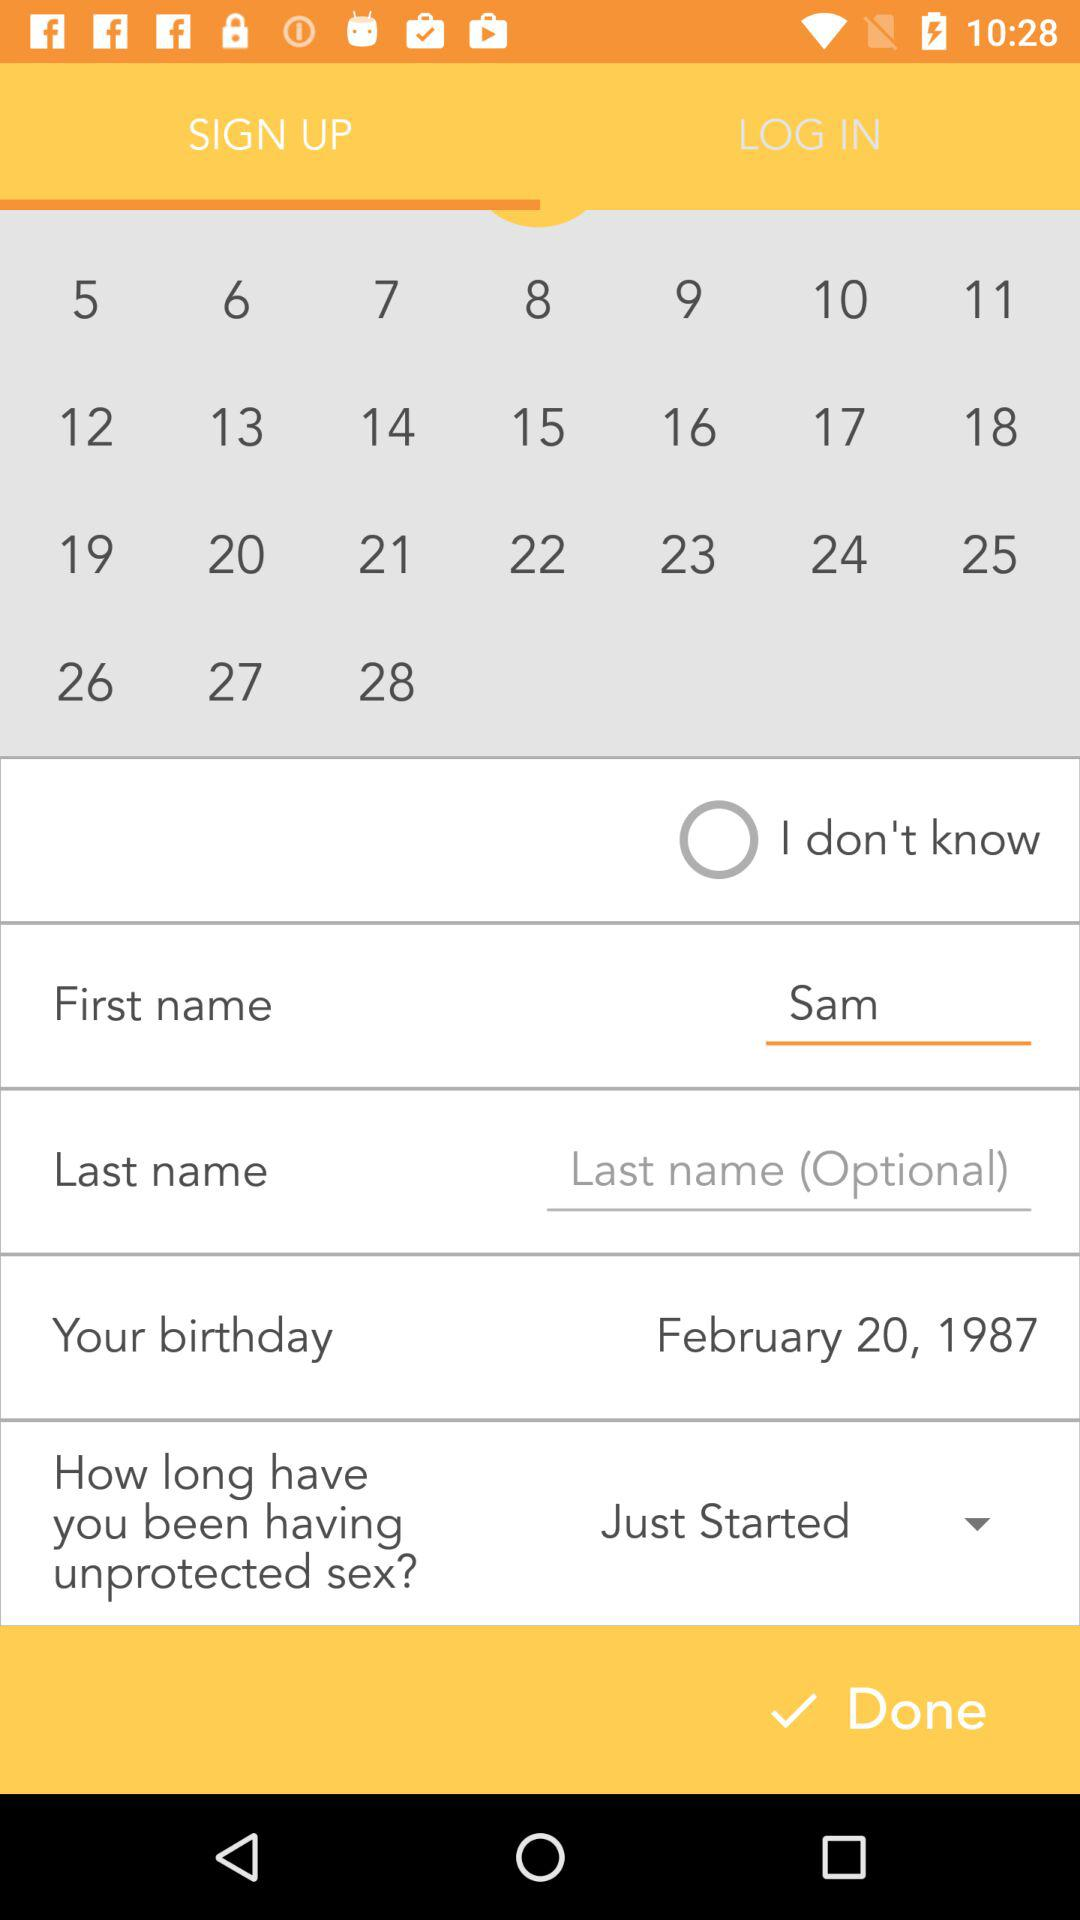What is the first name? The first name is Sam. 